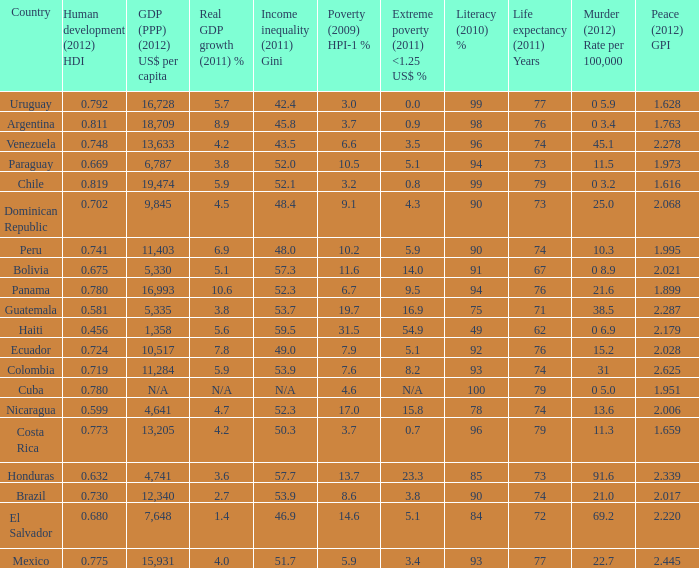What murder (2012) rate per 100,00 also has a 1.616 as the peace (2012) GPI? 0 3.2. 